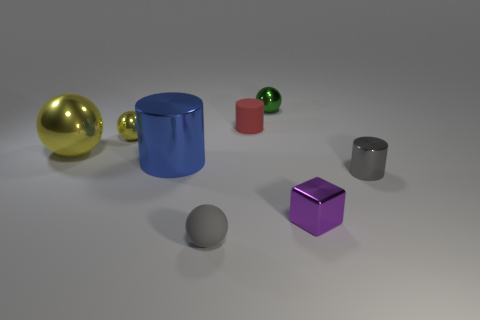Subtract all red cubes. Subtract all green spheres. How many cubes are left? 1 Add 1 big red cylinders. How many objects exist? 9 Subtract all cylinders. How many objects are left? 5 Add 8 blue objects. How many blue objects are left? 9 Add 1 big gray metal cylinders. How many big gray metal cylinders exist? 1 Subtract 2 yellow spheres. How many objects are left? 6 Subtract all big blue cylinders. Subtract all green matte cylinders. How many objects are left? 7 